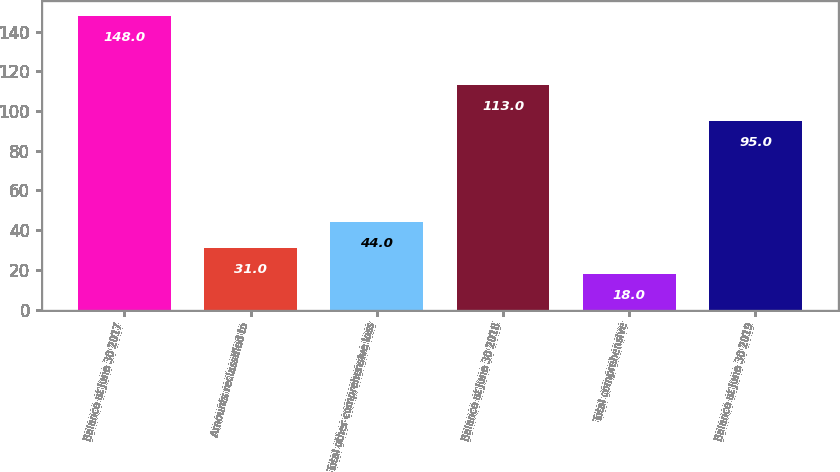Convert chart. <chart><loc_0><loc_0><loc_500><loc_500><bar_chart><fcel>Balance at June 30 2017<fcel>Amounts reclassified to<fcel>Total other comprehensive loss<fcel>Balance at June 30 2018<fcel>Total comprehensive<fcel>Balance at June 30 2019<nl><fcel>148<fcel>31<fcel>44<fcel>113<fcel>18<fcel>95<nl></chart> 